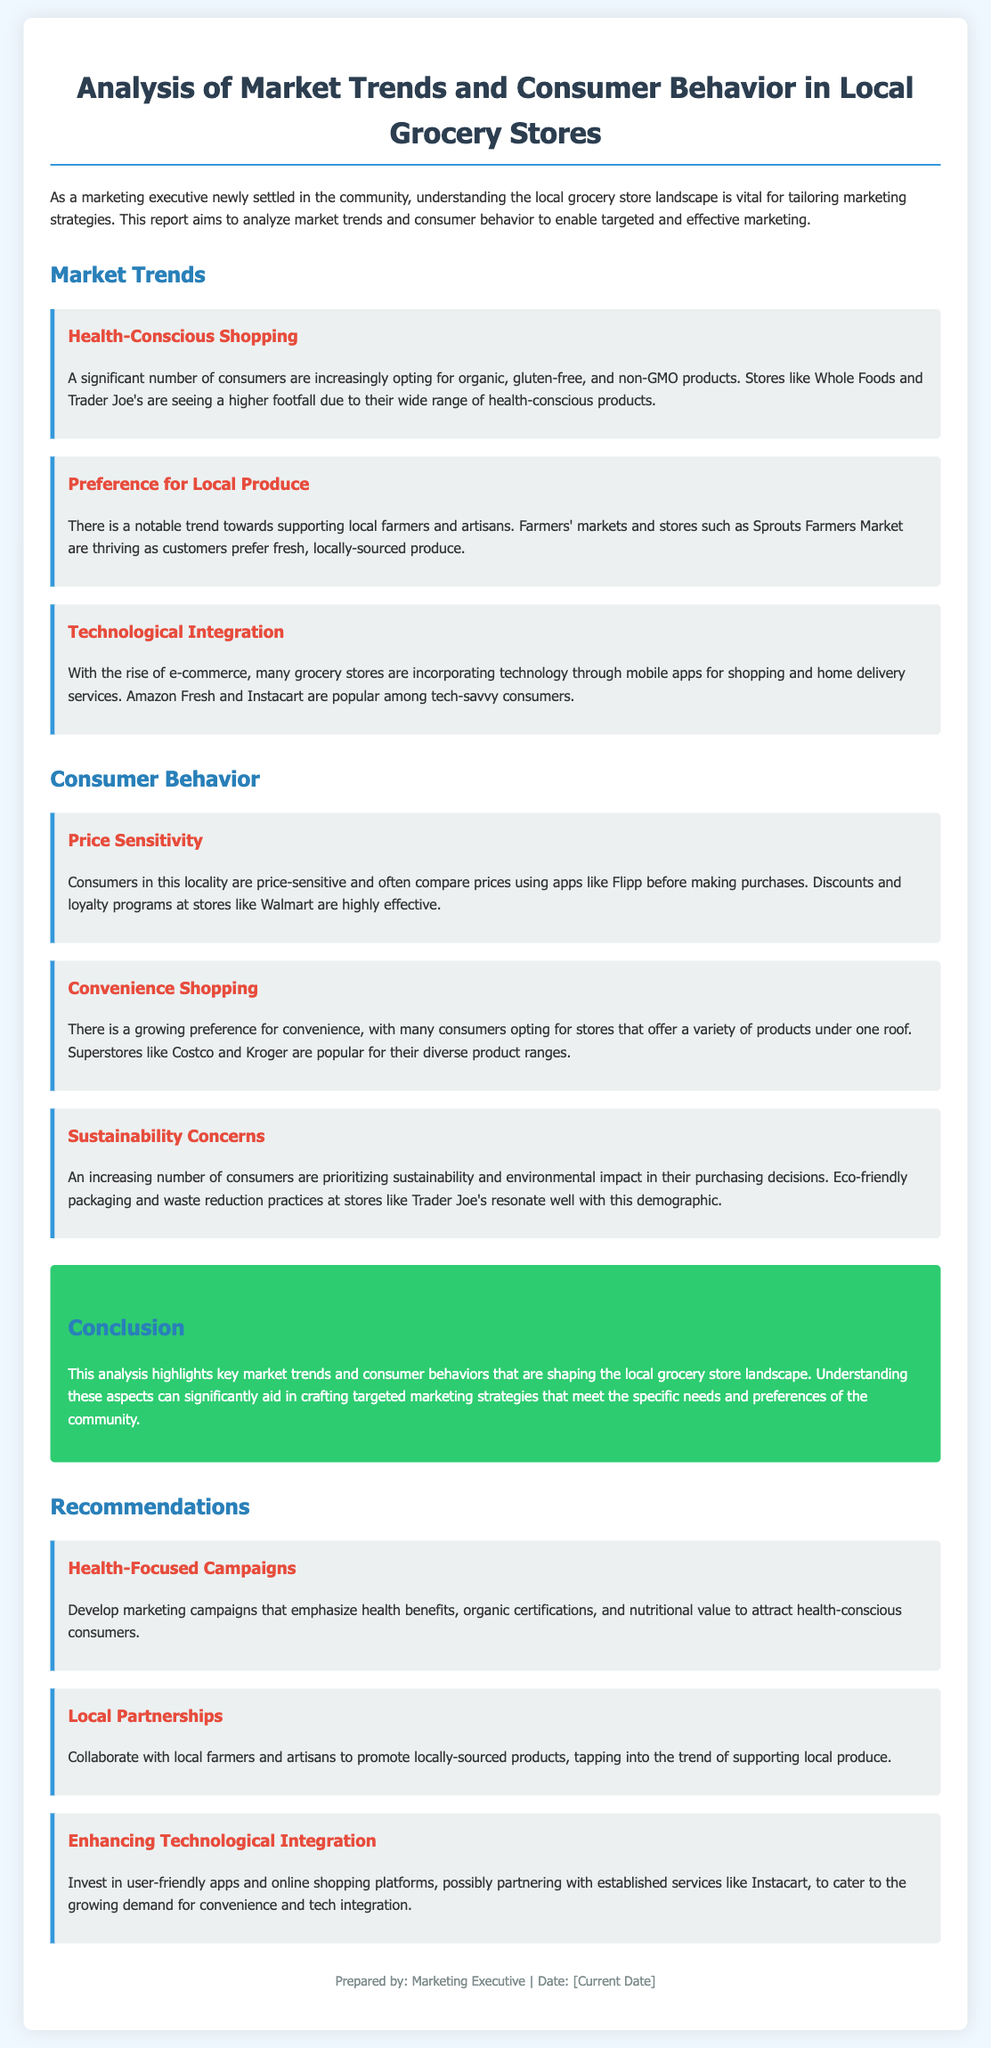What are some examples of health-conscious products? The document mentions organic, gluten-free, and non-GMO products as health-conscious options that consumers are opting for.
Answer: Organic, gluten-free, and non-GMO products Which grocery store is thriving due to the trend of supporting local farmers? The report states that Sprouts Farmers Market is thriving as customers prefer fresh, locally-sourced produce.
Answer: Sprouts Farmers Market What is a significant reason consumers use apps like Flipp? The document indicates that consumers use apps like Flipp to compare prices before making purchases, signaling their price sensitivity.
Answer: Compare prices What does the report suggest for marketing campaigns targeting health-conscious consumers? The recommendation is to develop marketing campaigns that emphasize health benefits, organic certifications, and nutritional value.
Answer: Health benefits What consumer behavior is increasing in the locality according to the report? The report points out that convenience shopping is on the rise, as consumers prefer stores offering a variety of products under one roof.
Answer: Convenience shopping How does the document classify the growing concern among consumers regarding sustainability? The document identifies sustainability and environmental impact as priorities for consumers in their purchasing decisions.
Answer: Sustainability concerns What campaign is recommended for promoting locally-sourced products? The report suggests collaborating with local farmers and artisans to promote locally-sourced products as a strategy.
Answer: Local partnerships Which stores are popular for diverse product ranges? The document lists superstores like Costco and Kroger as popular options for offering a variety of products under one roof.
Answer: Costco and Kroger Which technology-related service is suggested for improving grocery shopping? The recommendation includes investing in user-friendly apps and online shopping platforms, especially partnering with services like Instacart.
Answer: Instacart 